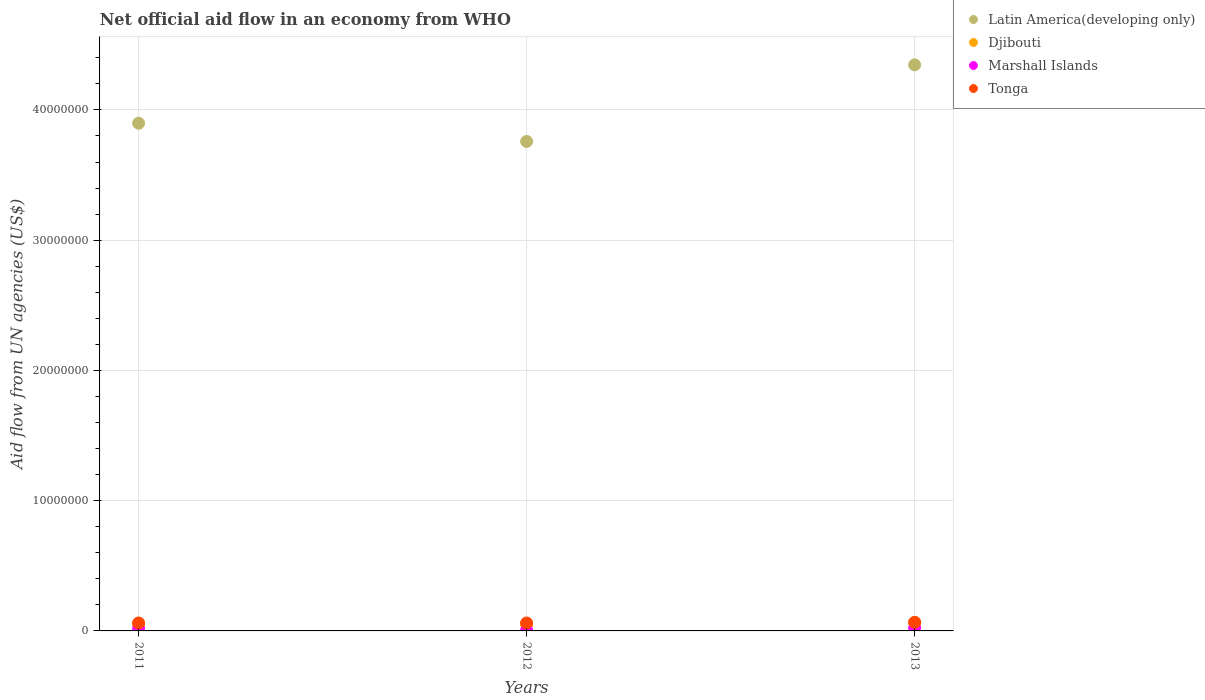How many different coloured dotlines are there?
Provide a succinct answer. 4. Is the number of dotlines equal to the number of legend labels?
Make the answer very short. Yes. What is the net official aid flow in Latin America(developing only) in 2011?
Your answer should be compact. 3.90e+07. Across all years, what is the maximum net official aid flow in Djibouti?
Offer a very short reply. 6.50e+05. Across all years, what is the minimum net official aid flow in Djibouti?
Ensure brevity in your answer.  5.20e+05. In which year was the net official aid flow in Latin America(developing only) maximum?
Your response must be concise. 2013. In which year was the net official aid flow in Djibouti minimum?
Ensure brevity in your answer.  2012. What is the total net official aid flow in Latin America(developing only) in the graph?
Your response must be concise. 1.20e+08. What is the difference between the net official aid flow in Djibouti in 2013 and the net official aid flow in Tonga in 2012?
Your response must be concise. 4.00e+04. What is the average net official aid flow in Tonga per year?
Provide a short and direct response. 6.27e+05. In the year 2011, what is the difference between the net official aid flow in Latin America(developing only) and net official aid flow in Djibouti?
Your response must be concise. 3.84e+07. What is the ratio of the net official aid flow in Djibouti in 2011 to that in 2012?
Provide a succinct answer. 1.04. Is the net official aid flow in Djibouti in 2012 less than that in 2013?
Your answer should be very brief. Yes. What is the difference between the highest and the lowest net official aid flow in Marshall Islands?
Give a very brief answer. 1.70e+05. In how many years, is the net official aid flow in Djibouti greater than the average net official aid flow in Djibouti taken over all years?
Offer a terse response. 1. Does the net official aid flow in Latin America(developing only) monotonically increase over the years?
Provide a short and direct response. No. Does the graph contain any zero values?
Provide a succinct answer. No. Where does the legend appear in the graph?
Provide a succinct answer. Top right. How many legend labels are there?
Provide a succinct answer. 4. What is the title of the graph?
Keep it short and to the point. Net official aid flow in an economy from WHO. What is the label or title of the Y-axis?
Your response must be concise. Aid flow from UN agencies (US$). What is the Aid flow from UN agencies (US$) of Latin America(developing only) in 2011?
Keep it short and to the point. 3.90e+07. What is the Aid flow from UN agencies (US$) of Djibouti in 2011?
Provide a succinct answer. 5.40e+05. What is the Aid flow from UN agencies (US$) of Tonga in 2011?
Offer a terse response. 6.10e+05. What is the Aid flow from UN agencies (US$) of Latin America(developing only) in 2012?
Your answer should be very brief. 3.76e+07. What is the Aid flow from UN agencies (US$) in Djibouti in 2012?
Your response must be concise. 5.20e+05. What is the Aid flow from UN agencies (US$) of Tonga in 2012?
Your answer should be very brief. 6.10e+05. What is the Aid flow from UN agencies (US$) in Latin America(developing only) in 2013?
Give a very brief answer. 4.35e+07. What is the Aid flow from UN agencies (US$) in Djibouti in 2013?
Ensure brevity in your answer.  6.50e+05. Across all years, what is the maximum Aid flow from UN agencies (US$) in Latin America(developing only)?
Offer a terse response. 4.35e+07. Across all years, what is the maximum Aid flow from UN agencies (US$) of Djibouti?
Offer a very short reply. 6.50e+05. Across all years, what is the minimum Aid flow from UN agencies (US$) in Latin America(developing only)?
Your answer should be compact. 3.76e+07. Across all years, what is the minimum Aid flow from UN agencies (US$) in Djibouti?
Ensure brevity in your answer.  5.20e+05. Across all years, what is the minimum Aid flow from UN agencies (US$) of Marshall Islands?
Your answer should be very brief. 5.00e+04. What is the total Aid flow from UN agencies (US$) of Latin America(developing only) in the graph?
Give a very brief answer. 1.20e+08. What is the total Aid flow from UN agencies (US$) in Djibouti in the graph?
Offer a very short reply. 1.71e+06. What is the total Aid flow from UN agencies (US$) in Marshall Islands in the graph?
Keep it short and to the point. 4.30e+05. What is the total Aid flow from UN agencies (US$) of Tonga in the graph?
Keep it short and to the point. 1.88e+06. What is the difference between the Aid flow from UN agencies (US$) in Latin America(developing only) in 2011 and that in 2012?
Your answer should be compact. 1.40e+06. What is the difference between the Aid flow from UN agencies (US$) in Djibouti in 2011 and that in 2012?
Provide a succinct answer. 2.00e+04. What is the difference between the Aid flow from UN agencies (US$) of Latin America(developing only) in 2011 and that in 2013?
Your answer should be compact. -4.48e+06. What is the difference between the Aid flow from UN agencies (US$) of Djibouti in 2011 and that in 2013?
Make the answer very short. -1.10e+05. What is the difference between the Aid flow from UN agencies (US$) of Tonga in 2011 and that in 2013?
Provide a succinct answer. -5.00e+04. What is the difference between the Aid flow from UN agencies (US$) of Latin America(developing only) in 2012 and that in 2013?
Give a very brief answer. -5.88e+06. What is the difference between the Aid flow from UN agencies (US$) of Djibouti in 2012 and that in 2013?
Provide a succinct answer. -1.30e+05. What is the difference between the Aid flow from UN agencies (US$) in Tonga in 2012 and that in 2013?
Give a very brief answer. -5.00e+04. What is the difference between the Aid flow from UN agencies (US$) of Latin America(developing only) in 2011 and the Aid flow from UN agencies (US$) of Djibouti in 2012?
Your answer should be very brief. 3.85e+07. What is the difference between the Aid flow from UN agencies (US$) in Latin America(developing only) in 2011 and the Aid flow from UN agencies (US$) in Marshall Islands in 2012?
Make the answer very short. 3.89e+07. What is the difference between the Aid flow from UN agencies (US$) in Latin America(developing only) in 2011 and the Aid flow from UN agencies (US$) in Tonga in 2012?
Your answer should be compact. 3.84e+07. What is the difference between the Aid flow from UN agencies (US$) of Djibouti in 2011 and the Aid flow from UN agencies (US$) of Tonga in 2012?
Provide a short and direct response. -7.00e+04. What is the difference between the Aid flow from UN agencies (US$) of Marshall Islands in 2011 and the Aid flow from UN agencies (US$) of Tonga in 2012?
Provide a short and direct response. -4.50e+05. What is the difference between the Aid flow from UN agencies (US$) in Latin America(developing only) in 2011 and the Aid flow from UN agencies (US$) in Djibouti in 2013?
Give a very brief answer. 3.83e+07. What is the difference between the Aid flow from UN agencies (US$) of Latin America(developing only) in 2011 and the Aid flow from UN agencies (US$) of Marshall Islands in 2013?
Give a very brief answer. 3.88e+07. What is the difference between the Aid flow from UN agencies (US$) in Latin America(developing only) in 2011 and the Aid flow from UN agencies (US$) in Tonga in 2013?
Offer a very short reply. 3.83e+07. What is the difference between the Aid flow from UN agencies (US$) of Djibouti in 2011 and the Aid flow from UN agencies (US$) of Tonga in 2013?
Provide a succinct answer. -1.20e+05. What is the difference between the Aid flow from UN agencies (US$) of Marshall Islands in 2011 and the Aid flow from UN agencies (US$) of Tonga in 2013?
Your answer should be very brief. -5.00e+05. What is the difference between the Aid flow from UN agencies (US$) of Latin America(developing only) in 2012 and the Aid flow from UN agencies (US$) of Djibouti in 2013?
Keep it short and to the point. 3.69e+07. What is the difference between the Aid flow from UN agencies (US$) of Latin America(developing only) in 2012 and the Aid flow from UN agencies (US$) of Marshall Islands in 2013?
Keep it short and to the point. 3.74e+07. What is the difference between the Aid flow from UN agencies (US$) of Latin America(developing only) in 2012 and the Aid flow from UN agencies (US$) of Tonga in 2013?
Your response must be concise. 3.69e+07. What is the difference between the Aid flow from UN agencies (US$) of Djibouti in 2012 and the Aid flow from UN agencies (US$) of Marshall Islands in 2013?
Provide a succinct answer. 3.00e+05. What is the difference between the Aid flow from UN agencies (US$) of Marshall Islands in 2012 and the Aid flow from UN agencies (US$) of Tonga in 2013?
Make the answer very short. -6.10e+05. What is the average Aid flow from UN agencies (US$) in Latin America(developing only) per year?
Offer a very short reply. 4.00e+07. What is the average Aid flow from UN agencies (US$) of Djibouti per year?
Your response must be concise. 5.70e+05. What is the average Aid flow from UN agencies (US$) in Marshall Islands per year?
Ensure brevity in your answer.  1.43e+05. What is the average Aid flow from UN agencies (US$) of Tonga per year?
Offer a very short reply. 6.27e+05. In the year 2011, what is the difference between the Aid flow from UN agencies (US$) of Latin America(developing only) and Aid flow from UN agencies (US$) of Djibouti?
Your answer should be very brief. 3.84e+07. In the year 2011, what is the difference between the Aid flow from UN agencies (US$) in Latin America(developing only) and Aid flow from UN agencies (US$) in Marshall Islands?
Your response must be concise. 3.88e+07. In the year 2011, what is the difference between the Aid flow from UN agencies (US$) of Latin America(developing only) and Aid flow from UN agencies (US$) of Tonga?
Offer a very short reply. 3.84e+07. In the year 2011, what is the difference between the Aid flow from UN agencies (US$) in Djibouti and Aid flow from UN agencies (US$) in Marshall Islands?
Keep it short and to the point. 3.80e+05. In the year 2011, what is the difference between the Aid flow from UN agencies (US$) in Marshall Islands and Aid flow from UN agencies (US$) in Tonga?
Provide a succinct answer. -4.50e+05. In the year 2012, what is the difference between the Aid flow from UN agencies (US$) in Latin America(developing only) and Aid flow from UN agencies (US$) in Djibouti?
Offer a terse response. 3.71e+07. In the year 2012, what is the difference between the Aid flow from UN agencies (US$) in Latin America(developing only) and Aid flow from UN agencies (US$) in Marshall Islands?
Offer a very short reply. 3.75e+07. In the year 2012, what is the difference between the Aid flow from UN agencies (US$) in Latin America(developing only) and Aid flow from UN agencies (US$) in Tonga?
Provide a succinct answer. 3.70e+07. In the year 2012, what is the difference between the Aid flow from UN agencies (US$) of Marshall Islands and Aid flow from UN agencies (US$) of Tonga?
Ensure brevity in your answer.  -5.60e+05. In the year 2013, what is the difference between the Aid flow from UN agencies (US$) of Latin America(developing only) and Aid flow from UN agencies (US$) of Djibouti?
Your answer should be compact. 4.28e+07. In the year 2013, what is the difference between the Aid flow from UN agencies (US$) in Latin America(developing only) and Aid flow from UN agencies (US$) in Marshall Islands?
Keep it short and to the point. 4.32e+07. In the year 2013, what is the difference between the Aid flow from UN agencies (US$) of Latin America(developing only) and Aid flow from UN agencies (US$) of Tonga?
Your answer should be very brief. 4.28e+07. In the year 2013, what is the difference between the Aid flow from UN agencies (US$) in Djibouti and Aid flow from UN agencies (US$) in Tonga?
Make the answer very short. -10000. In the year 2013, what is the difference between the Aid flow from UN agencies (US$) of Marshall Islands and Aid flow from UN agencies (US$) of Tonga?
Keep it short and to the point. -4.40e+05. What is the ratio of the Aid flow from UN agencies (US$) in Latin America(developing only) in 2011 to that in 2012?
Make the answer very short. 1.04. What is the ratio of the Aid flow from UN agencies (US$) in Djibouti in 2011 to that in 2012?
Your response must be concise. 1.04. What is the ratio of the Aid flow from UN agencies (US$) of Marshall Islands in 2011 to that in 2012?
Give a very brief answer. 3.2. What is the ratio of the Aid flow from UN agencies (US$) in Latin America(developing only) in 2011 to that in 2013?
Your answer should be very brief. 0.9. What is the ratio of the Aid flow from UN agencies (US$) of Djibouti in 2011 to that in 2013?
Keep it short and to the point. 0.83. What is the ratio of the Aid flow from UN agencies (US$) in Marshall Islands in 2011 to that in 2013?
Make the answer very short. 0.73. What is the ratio of the Aid flow from UN agencies (US$) in Tonga in 2011 to that in 2013?
Ensure brevity in your answer.  0.92. What is the ratio of the Aid flow from UN agencies (US$) of Latin America(developing only) in 2012 to that in 2013?
Provide a short and direct response. 0.86. What is the ratio of the Aid flow from UN agencies (US$) of Marshall Islands in 2012 to that in 2013?
Offer a terse response. 0.23. What is the ratio of the Aid flow from UN agencies (US$) in Tonga in 2012 to that in 2013?
Provide a succinct answer. 0.92. What is the difference between the highest and the second highest Aid flow from UN agencies (US$) in Latin America(developing only)?
Your answer should be compact. 4.48e+06. What is the difference between the highest and the second highest Aid flow from UN agencies (US$) of Djibouti?
Give a very brief answer. 1.10e+05. What is the difference between the highest and the second highest Aid flow from UN agencies (US$) of Marshall Islands?
Your answer should be very brief. 6.00e+04. What is the difference between the highest and the second highest Aid flow from UN agencies (US$) of Tonga?
Your response must be concise. 5.00e+04. What is the difference between the highest and the lowest Aid flow from UN agencies (US$) in Latin America(developing only)?
Offer a terse response. 5.88e+06. What is the difference between the highest and the lowest Aid flow from UN agencies (US$) in Marshall Islands?
Keep it short and to the point. 1.70e+05. What is the difference between the highest and the lowest Aid flow from UN agencies (US$) in Tonga?
Your answer should be compact. 5.00e+04. 